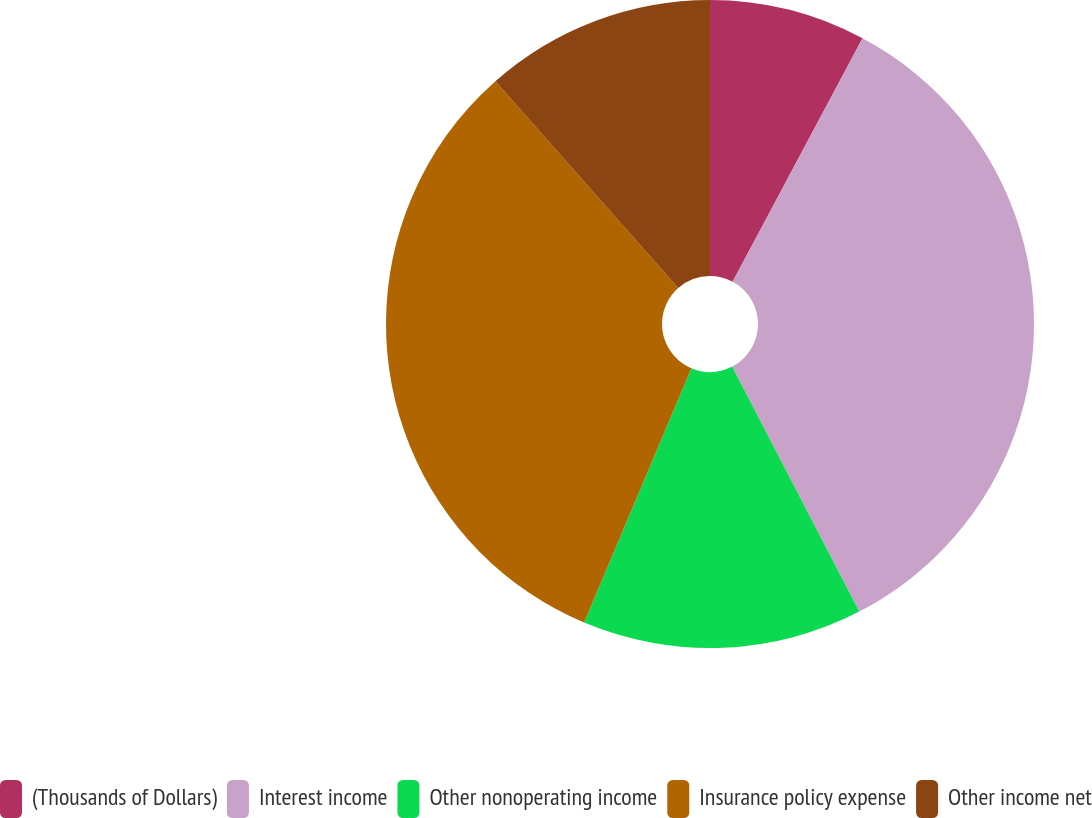<chart> <loc_0><loc_0><loc_500><loc_500><pie_chart><fcel>(Thousands of Dollars)<fcel>Interest income<fcel>Other nonoperating income<fcel>Insurance policy expense<fcel>Other income net<nl><fcel>7.8%<fcel>34.58%<fcel>13.97%<fcel>32.13%<fcel>11.52%<nl></chart> 